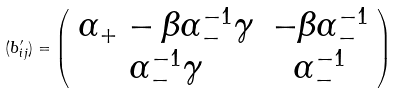<formula> <loc_0><loc_0><loc_500><loc_500>( b ^ { \prime } _ { i j } ) = \left ( \begin{array} { c c } \alpha _ { + } - \beta \alpha ^ { - 1 } _ { - } \gamma & - \beta \alpha _ { - } ^ { - 1 } \\ \alpha _ { - } ^ { - 1 } \gamma & \alpha _ { - } ^ { - 1 } \end{array} \right )</formula> 